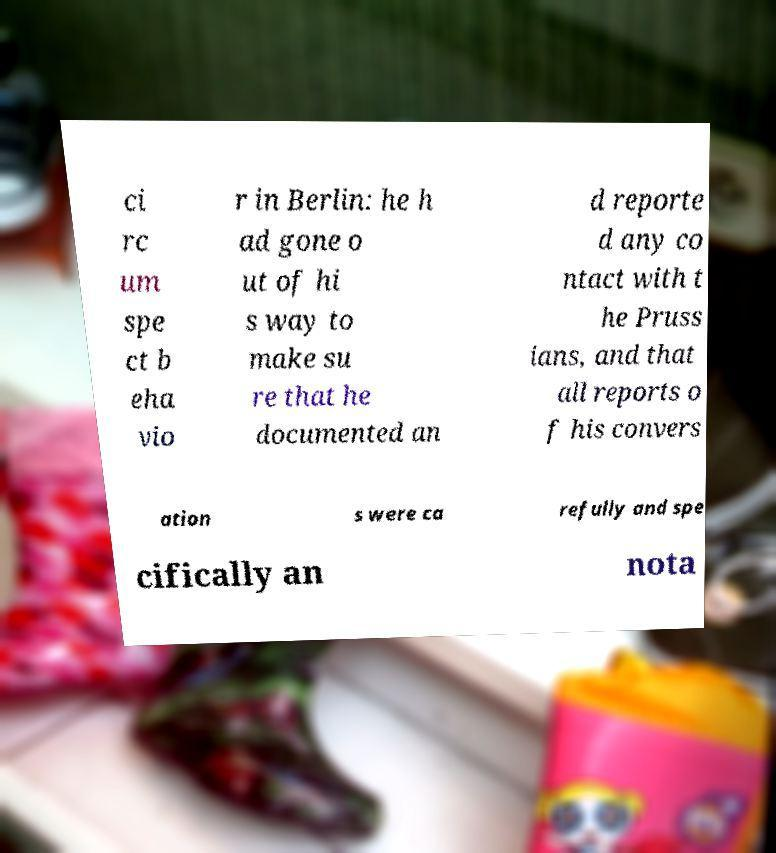For documentation purposes, I need the text within this image transcribed. Could you provide that? ci rc um spe ct b eha vio r in Berlin: he h ad gone o ut of hi s way to make su re that he documented an d reporte d any co ntact with t he Pruss ians, and that all reports o f his convers ation s were ca refully and spe cifically an nota 